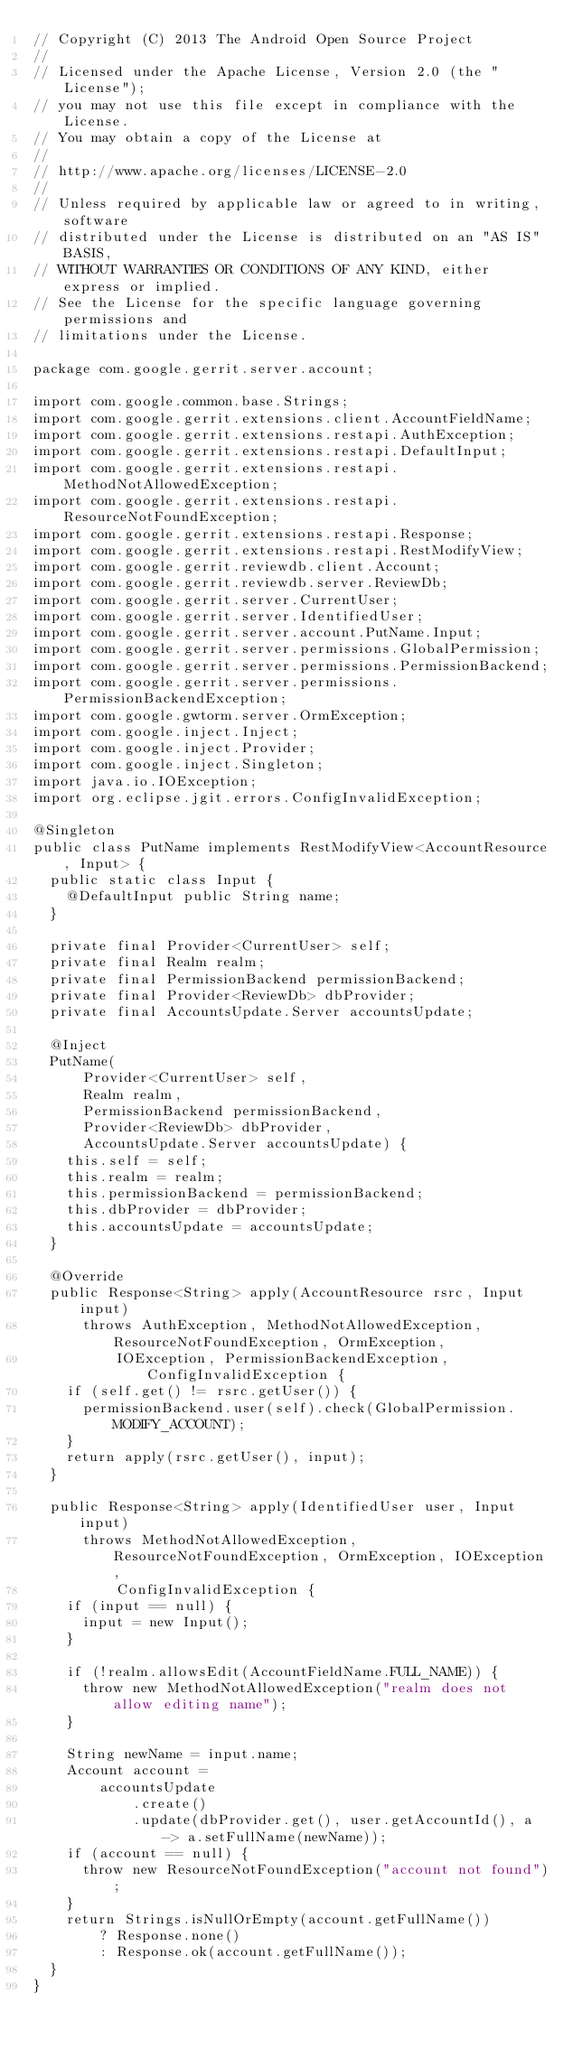<code> <loc_0><loc_0><loc_500><loc_500><_Java_>// Copyright (C) 2013 The Android Open Source Project
//
// Licensed under the Apache License, Version 2.0 (the "License");
// you may not use this file except in compliance with the License.
// You may obtain a copy of the License at
//
// http://www.apache.org/licenses/LICENSE-2.0
//
// Unless required by applicable law or agreed to in writing, software
// distributed under the License is distributed on an "AS IS" BASIS,
// WITHOUT WARRANTIES OR CONDITIONS OF ANY KIND, either express or implied.
// See the License for the specific language governing permissions and
// limitations under the License.

package com.google.gerrit.server.account;

import com.google.common.base.Strings;
import com.google.gerrit.extensions.client.AccountFieldName;
import com.google.gerrit.extensions.restapi.AuthException;
import com.google.gerrit.extensions.restapi.DefaultInput;
import com.google.gerrit.extensions.restapi.MethodNotAllowedException;
import com.google.gerrit.extensions.restapi.ResourceNotFoundException;
import com.google.gerrit.extensions.restapi.Response;
import com.google.gerrit.extensions.restapi.RestModifyView;
import com.google.gerrit.reviewdb.client.Account;
import com.google.gerrit.reviewdb.server.ReviewDb;
import com.google.gerrit.server.CurrentUser;
import com.google.gerrit.server.IdentifiedUser;
import com.google.gerrit.server.account.PutName.Input;
import com.google.gerrit.server.permissions.GlobalPermission;
import com.google.gerrit.server.permissions.PermissionBackend;
import com.google.gerrit.server.permissions.PermissionBackendException;
import com.google.gwtorm.server.OrmException;
import com.google.inject.Inject;
import com.google.inject.Provider;
import com.google.inject.Singleton;
import java.io.IOException;
import org.eclipse.jgit.errors.ConfigInvalidException;

@Singleton
public class PutName implements RestModifyView<AccountResource, Input> {
  public static class Input {
    @DefaultInput public String name;
  }

  private final Provider<CurrentUser> self;
  private final Realm realm;
  private final PermissionBackend permissionBackend;
  private final Provider<ReviewDb> dbProvider;
  private final AccountsUpdate.Server accountsUpdate;

  @Inject
  PutName(
      Provider<CurrentUser> self,
      Realm realm,
      PermissionBackend permissionBackend,
      Provider<ReviewDb> dbProvider,
      AccountsUpdate.Server accountsUpdate) {
    this.self = self;
    this.realm = realm;
    this.permissionBackend = permissionBackend;
    this.dbProvider = dbProvider;
    this.accountsUpdate = accountsUpdate;
  }

  @Override
  public Response<String> apply(AccountResource rsrc, Input input)
      throws AuthException, MethodNotAllowedException, ResourceNotFoundException, OrmException,
          IOException, PermissionBackendException, ConfigInvalidException {
    if (self.get() != rsrc.getUser()) {
      permissionBackend.user(self).check(GlobalPermission.MODIFY_ACCOUNT);
    }
    return apply(rsrc.getUser(), input);
  }

  public Response<String> apply(IdentifiedUser user, Input input)
      throws MethodNotAllowedException, ResourceNotFoundException, OrmException, IOException,
          ConfigInvalidException {
    if (input == null) {
      input = new Input();
    }

    if (!realm.allowsEdit(AccountFieldName.FULL_NAME)) {
      throw new MethodNotAllowedException("realm does not allow editing name");
    }

    String newName = input.name;
    Account account =
        accountsUpdate
            .create()
            .update(dbProvider.get(), user.getAccountId(), a -> a.setFullName(newName));
    if (account == null) {
      throw new ResourceNotFoundException("account not found");
    }
    return Strings.isNullOrEmpty(account.getFullName())
        ? Response.none()
        : Response.ok(account.getFullName());
  }
}
</code> 